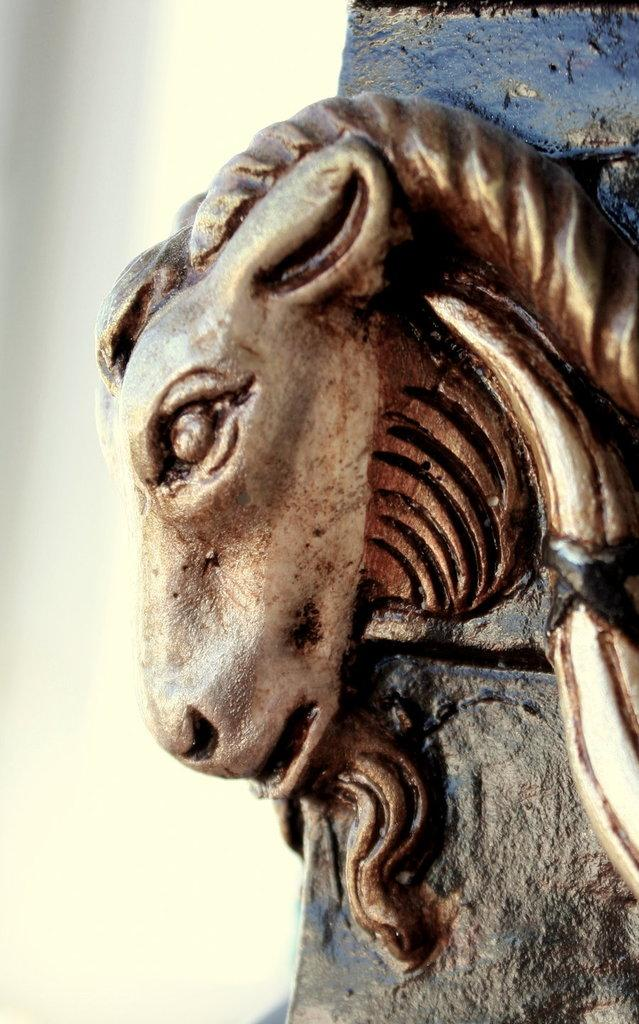What type of living creature is present in the image? There is an animal in the image. What type of rail can be seen in the image? There is no rail present in the image; it only features an animal. What kind of shoe is the animal wearing in the image? There is no shoe present in the image, as animals do not wear shoes. 